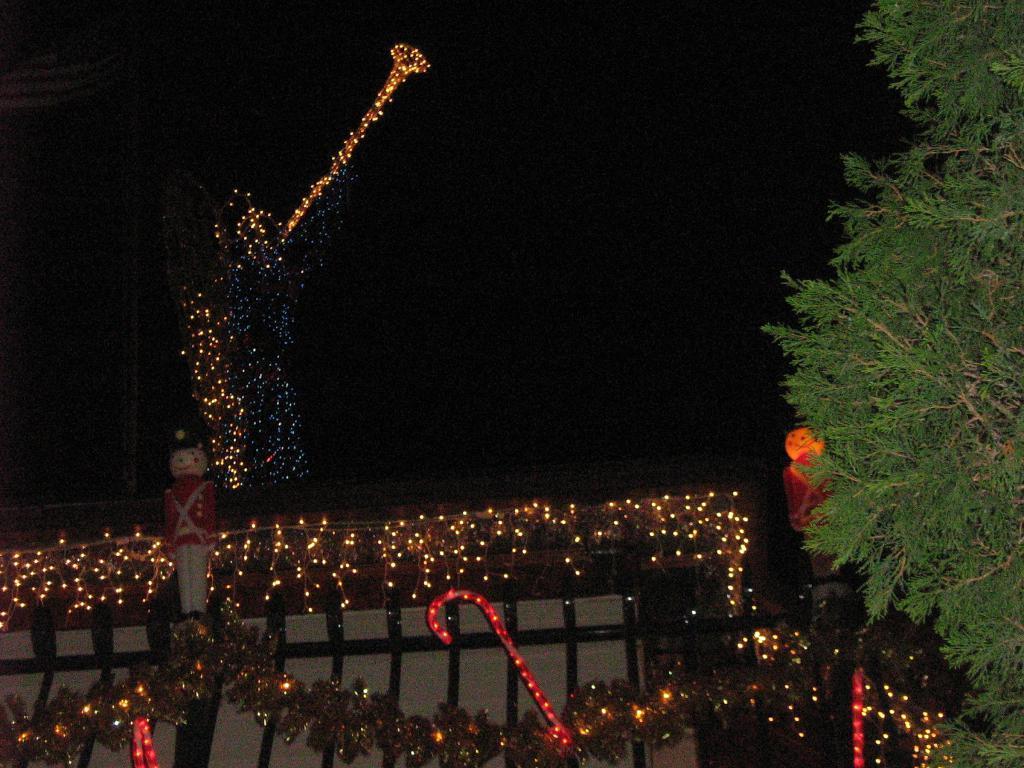Can you describe this image briefly? In this image, in the middle there are lightings, tree, house, toys, sky. 